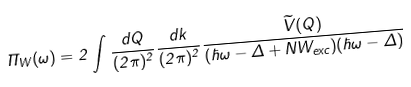Convert formula to latex. <formula><loc_0><loc_0><loc_500><loc_500>\Pi _ { W } ( \omega ) = 2 \int \frac { d Q } { ( 2 \pi ) ^ { 2 } } \frac { d k } { ( 2 \pi ) ^ { 2 } } \frac { \widetilde { V } ( Q ) } { ( \hbar { \omega } - \Delta + N W _ { e x c } ) ( \hbar { \omega } - \Delta ) }</formula> 